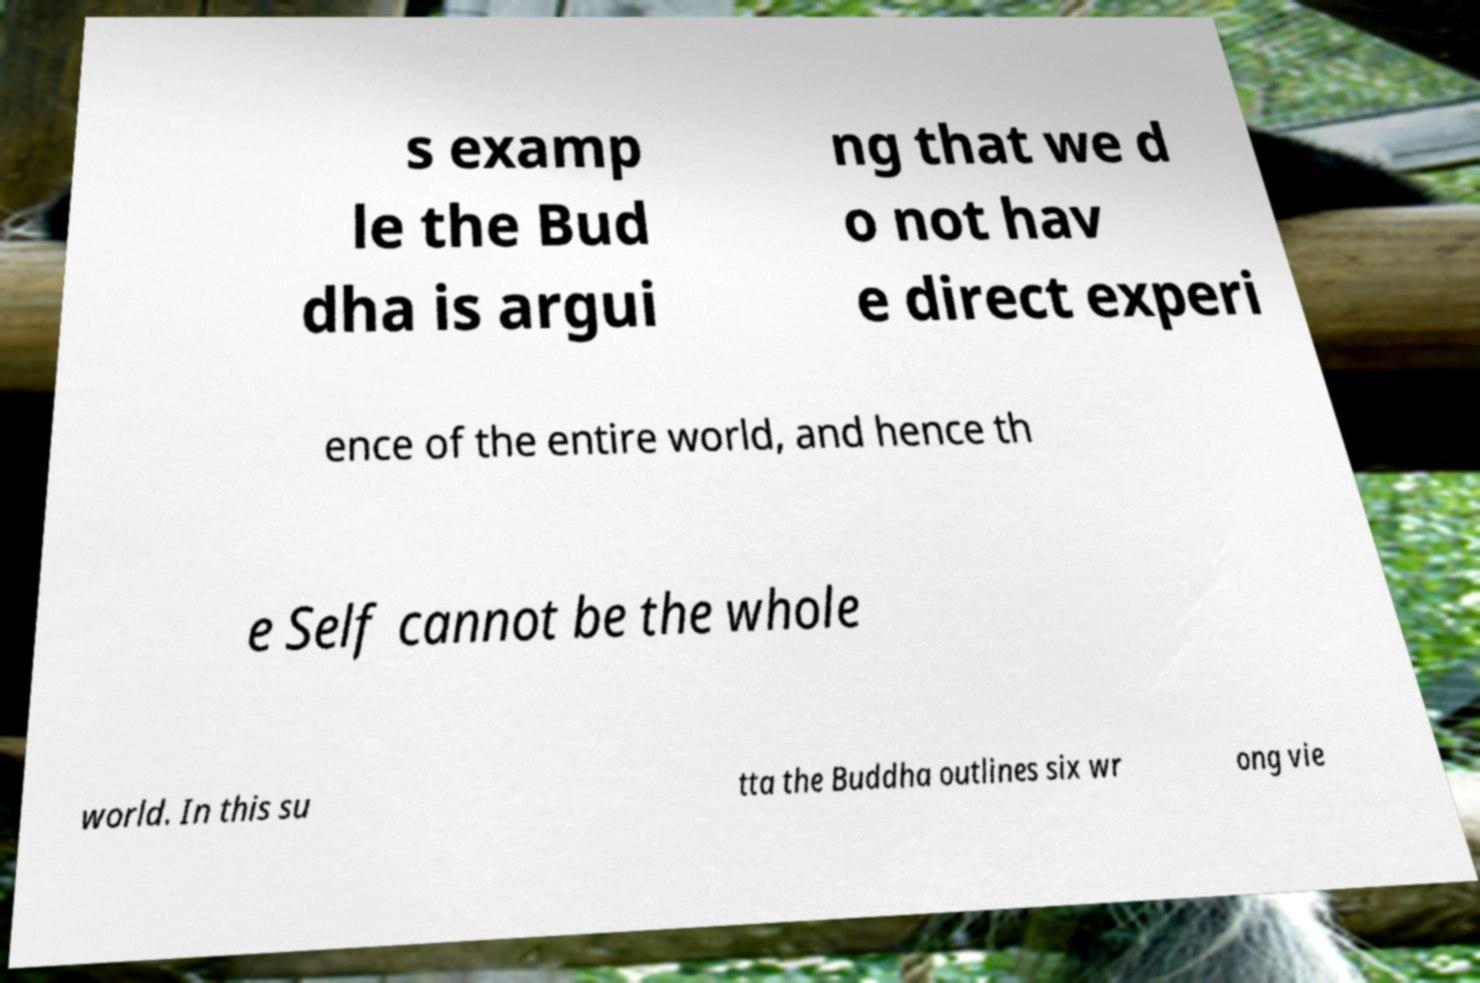Could you extract and type out the text from this image? s examp le the Bud dha is argui ng that we d o not hav e direct experi ence of the entire world, and hence th e Self cannot be the whole world. In this su tta the Buddha outlines six wr ong vie 